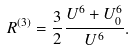Convert formula to latex. <formula><loc_0><loc_0><loc_500><loc_500>R ^ { ( 3 ) } = \frac { 3 } { 2 } \frac { U ^ { 6 } + U _ { 0 } ^ { 6 } } { U ^ { 6 } } .</formula> 